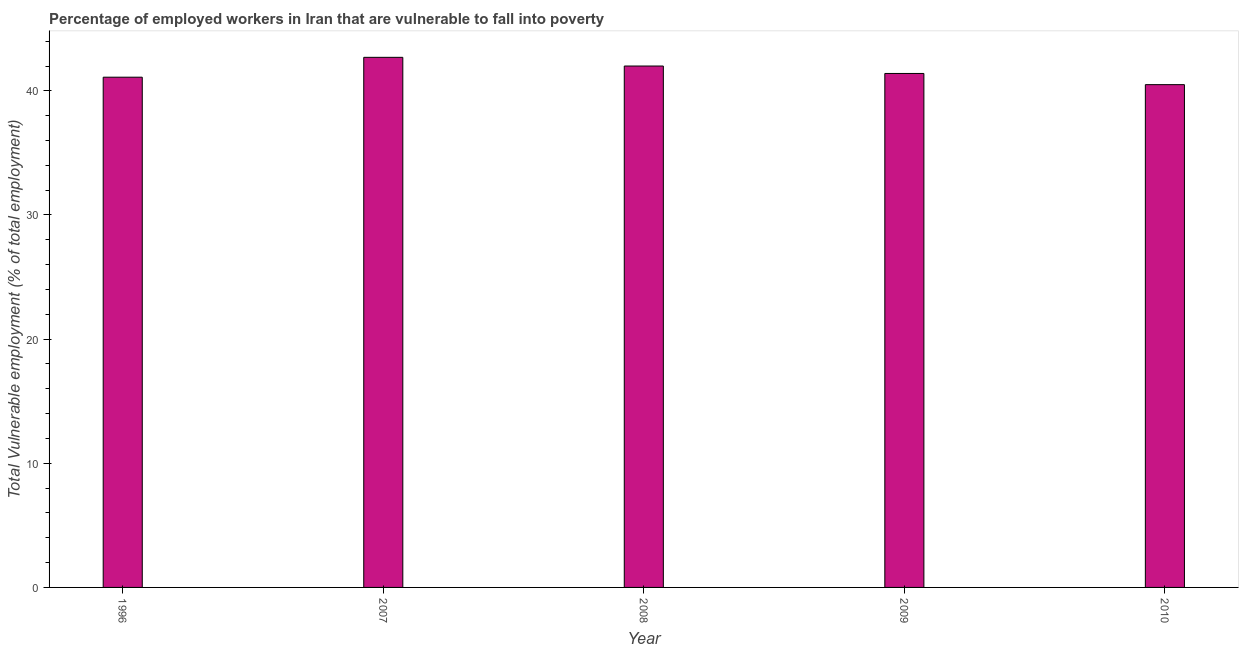What is the title of the graph?
Keep it short and to the point. Percentage of employed workers in Iran that are vulnerable to fall into poverty. What is the label or title of the X-axis?
Offer a terse response. Year. What is the label or title of the Y-axis?
Your answer should be very brief. Total Vulnerable employment (% of total employment). What is the total vulnerable employment in 2010?
Ensure brevity in your answer.  40.5. Across all years, what is the maximum total vulnerable employment?
Keep it short and to the point. 42.7. Across all years, what is the minimum total vulnerable employment?
Your response must be concise. 40.5. In which year was the total vulnerable employment maximum?
Your response must be concise. 2007. What is the sum of the total vulnerable employment?
Give a very brief answer. 207.7. What is the average total vulnerable employment per year?
Offer a terse response. 41.54. What is the median total vulnerable employment?
Provide a short and direct response. 41.4. In how many years, is the total vulnerable employment greater than 32 %?
Offer a very short reply. 5. Do a majority of the years between 2008 and 2010 (inclusive) have total vulnerable employment greater than 18 %?
Ensure brevity in your answer.  Yes. What is the ratio of the total vulnerable employment in 2007 to that in 2009?
Your answer should be very brief. 1.03. Is the total vulnerable employment in 2008 less than that in 2010?
Your answer should be very brief. No. Is the difference between the total vulnerable employment in 2008 and 2010 greater than the difference between any two years?
Offer a very short reply. No. Is the sum of the total vulnerable employment in 2008 and 2009 greater than the maximum total vulnerable employment across all years?
Offer a terse response. Yes. In how many years, is the total vulnerable employment greater than the average total vulnerable employment taken over all years?
Make the answer very short. 2. How many bars are there?
Give a very brief answer. 5. What is the difference between two consecutive major ticks on the Y-axis?
Provide a succinct answer. 10. What is the Total Vulnerable employment (% of total employment) in 1996?
Your answer should be very brief. 41.1. What is the Total Vulnerable employment (% of total employment) of 2007?
Your answer should be very brief. 42.7. What is the Total Vulnerable employment (% of total employment) in 2009?
Provide a short and direct response. 41.4. What is the Total Vulnerable employment (% of total employment) of 2010?
Your answer should be compact. 40.5. What is the difference between the Total Vulnerable employment (% of total employment) in 1996 and 2009?
Your answer should be very brief. -0.3. What is the difference between the Total Vulnerable employment (% of total employment) in 1996 and 2010?
Offer a terse response. 0.6. What is the difference between the Total Vulnerable employment (% of total employment) in 2007 and 2008?
Your answer should be very brief. 0.7. What is the difference between the Total Vulnerable employment (% of total employment) in 2007 and 2009?
Keep it short and to the point. 1.3. What is the difference between the Total Vulnerable employment (% of total employment) in 2008 and 2009?
Give a very brief answer. 0.6. What is the difference between the Total Vulnerable employment (% of total employment) in 2008 and 2010?
Ensure brevity in your answer.  1.5. What is the ratio of the Total Vulnerable employment (% of total employment) in 1996 to that in 2007?
Make the answer very short. 0.96. What is the ratio of the Total Vulnerable employment (% of total employment) in 1996 to that in 2008?
Keep it short and to the point. 0.98. What is the ratio of the Total Vulnerable employment (% of total employment) in 1996 to that in 2010?
Provide a short and direct response. 1.01. What is the ratio of the Total Vulnerable employment (% of total employment) in 2007 to that in 2009?
Provide a succinct answer. 1.03. What is the ratio of the Total Vulnerable employment (% of total employment) in 2007 to that in 2010?
Ensure brevity in your answer.  1.05. What is the ratio of the Total Vulnerable employment (% of total employment) in 2008 to that in 2009?
Make the answer very short. 1.01. What is the ratio of the Total Vulnerable employment (% of total employment) in 2009 to that in 2010?
Offer a terse response. 1.02. 